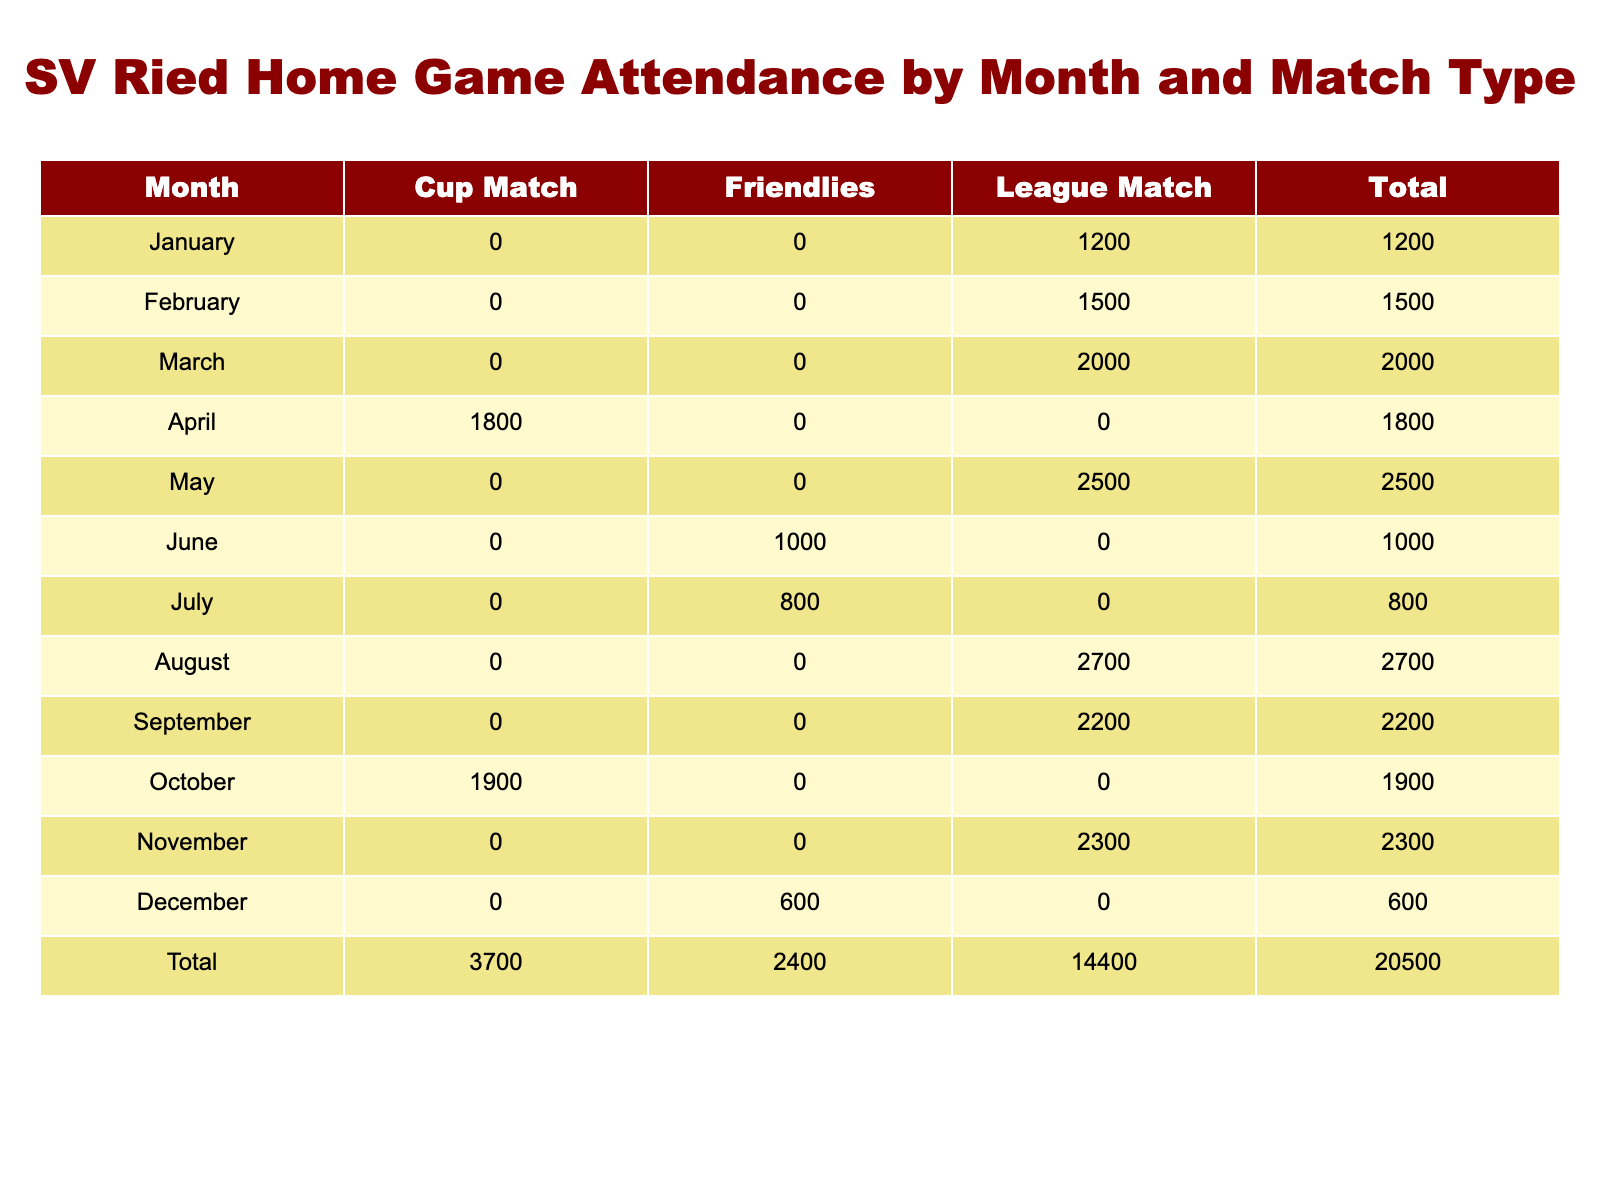What is the total attendance for SV Ried home games in January? From the table, we look under the "January" row where the attendance for a League Match is recorded as 1200. As there are no other match types for this month, the total attendance is simply that value.
Answer: 1200 Which month had the highest attendance for League Matches? Looking at the "League Match" column, we can see the attendance figures for League Matches: January (1200), February (1500), March (2000), May (2500), August (2700), September (2200), November (2300). The highest value is 2700 in August.
Answer: August What is the combined attendance for Cup Matches in April and October? In April, the attendance for a Cup Match is 1800, and in October, it is 1900. Adding these two values together gives us: 1800 + 1900 = 3700.
Answer: 3700 Did SV Ried have any Friendlies with an attendance greater than 1000? We check the "Friendlies" row, where the attendance values are: June (1000), July (800), and December (600). None of these values exceed 1000, therefore the answer is no.
Answer: No What is the average attendance for all matches held in June and July? The attendance for June (Friendlies) is 1000 and for July (Friendlies) is 800. To find the average, we sum these attendance figures: 1000 + 800 = 1800, and then divide by 2, which gives us: 1800 / 2 = 900.
Answer: 900 Which match type had the least total attendance when summed across all months? To determine this, we calculate the total attendance for each match type. League Matches total to: 1200 + 1500 + 2000 + 2500 + 2700 + 2200 + 2300 = 14500. For Cup Matches: 1800 + 1900 = 3700. And for Friendlies: 1000 + 800 + 600 = 2400. The least total attendance is for Friendlies (2400).
Answer: Friendlies What is the total attendance for SV Ried home games for the entire year? To find this, we total the attendance figures for all months. The sums for each month provide the following totals: League Matches (14500) + Cup Matches (3700) + Friendlies (2400) = 14500 + 3700 + 2400 = 19600.
Answer: 19600 Which month had lower attendance, May or November? For May, the attendance for a League Match is 2500, and in November, the attendance for a League Match is 2300. Comparing these figures, we see that 2300 is lower than 2500, so November has lower attendance.
Answer: November 